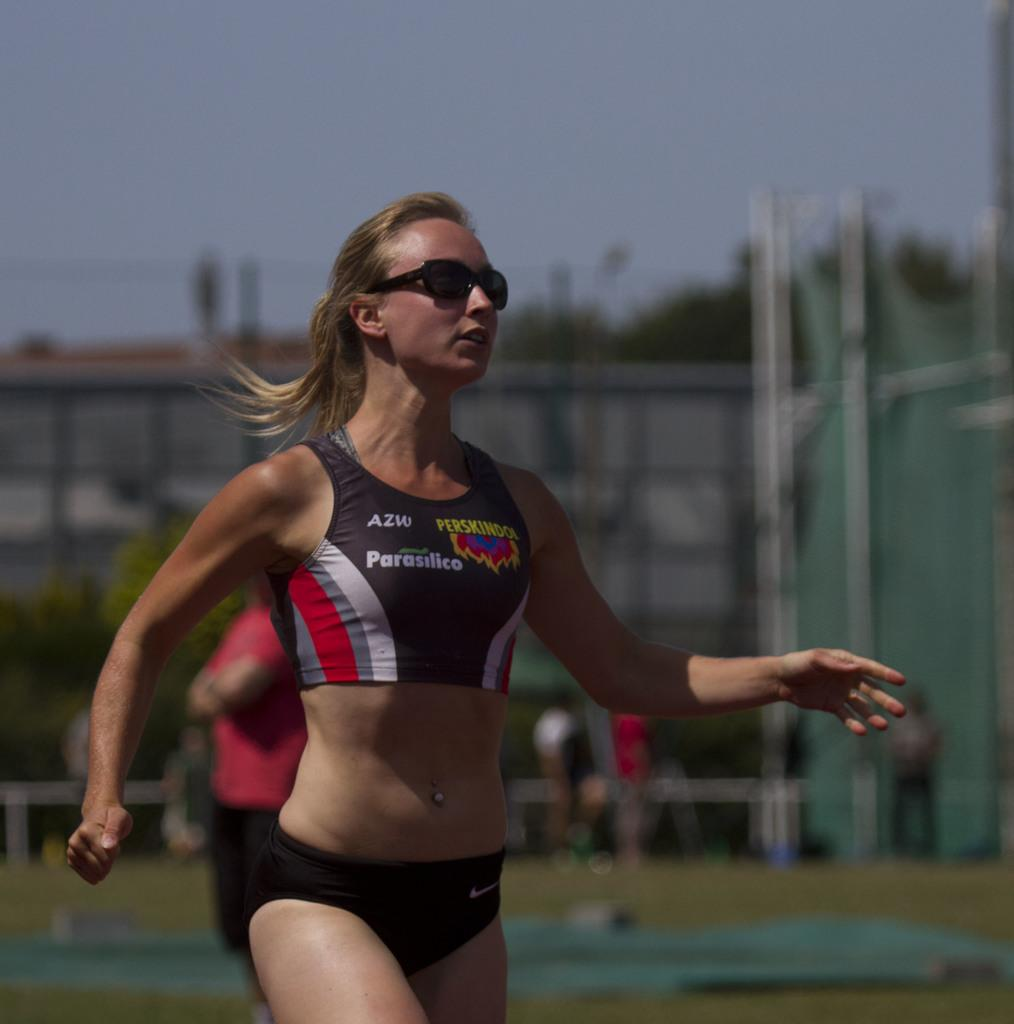Provide a one-sentence caption for the provided image. a woman runner in an AZW black and white outfit. 